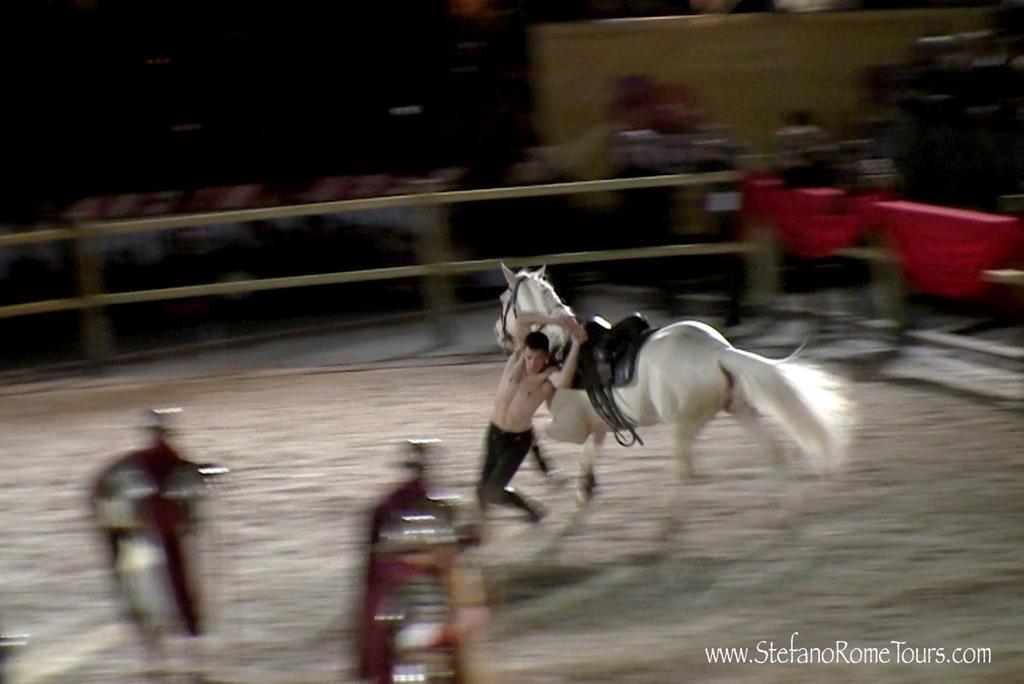Can you describe this image briefly? In this image I can see a man in the centre and behind him I can see a white colour horse. On the right side of this image I can see few red colour clothes and I can see this image is little bit blurry. On the bottom right side of this image I can see a watermark. 